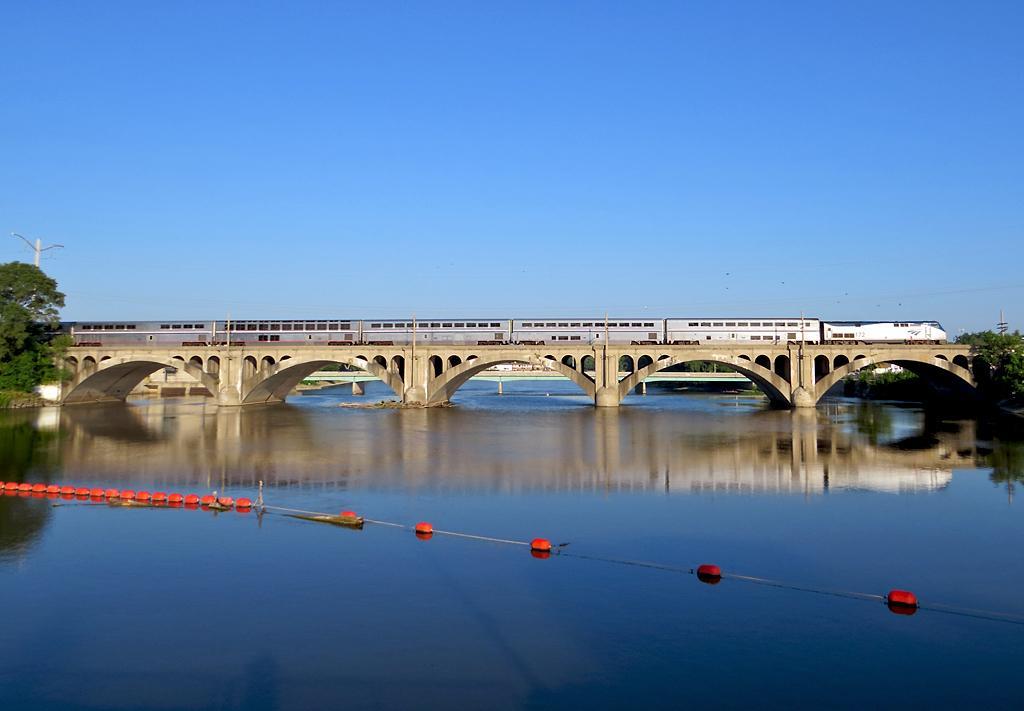In one or two sentences, can you explain what this image depicts? In this picture we can see red color objects with rope above the water. In the background of the image we can see train on the bridge, trees, poles and sky in blue color. 